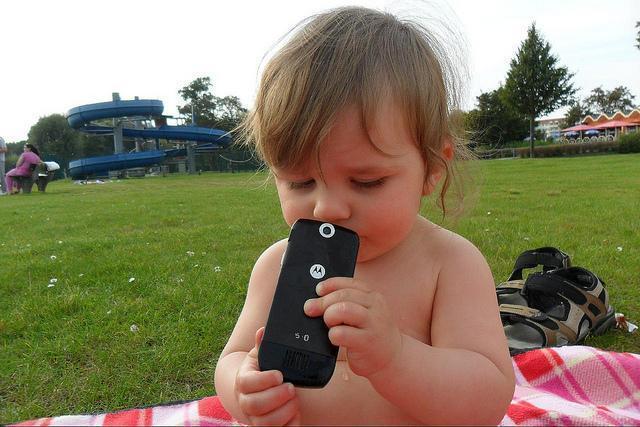What is playing with the phone?
Indicate the correct choice and explain in the format: 'Answer: answer
Rationale: rationale.'
Options: Baby, cat, bird, dog. Answer: baby.
Rationale: The baby plays. 